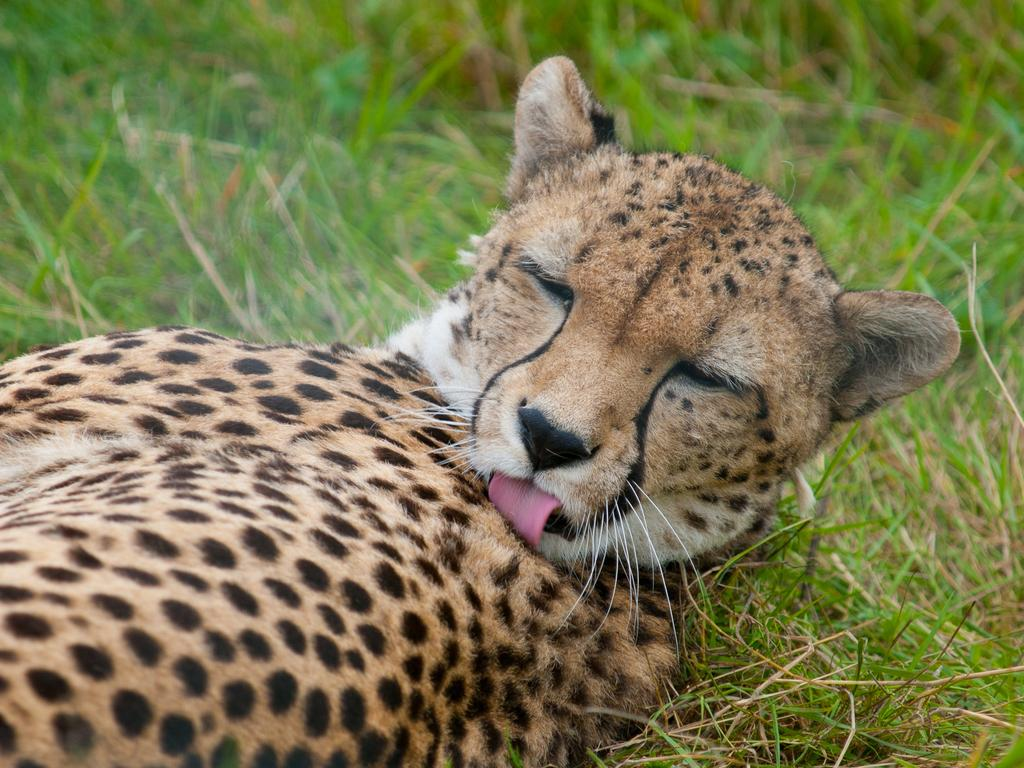What type of animal is in the image? There is a leopard in the image. What is the leopard's position in the image? The leopard is lying on a grassland. What type of riddle can be solved by the leopard in the image? There is no riddle present in the image, nor is there any indication that the leopard is solving a riddle. What type of tent can be seen in the image? There is no tent present in the image; it features a leopard lying on a grassland. 